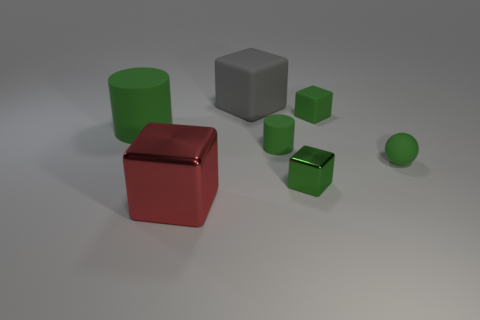Are the large red cube that is left of the tiny cylinder and the thing that is on the left side of the red shiny object made of the same material?
Ensure brevity in your answer.  No. Are there any small yellow cubes?
Ensure brevity in your answer.  No. Is the number of big red shiny blocks that are right of the large matte block greater than the number of large matte blocks that are on the left side of the large red thing?
Your answer should be compact. No. There is a red object that is the same shape as the tiny green metal object; what material is it?
Keep it short and to the point. Metal. Is there any other thing that has the same size as the gray rubber cube?
Your response must be concise. Yes. There is a large matte thing in front of the green rubber cube; is it the same color as the tiny rubber cylinder behind the small matte ball?
Your answer should be very brief. Yes. What is the shape of the red metal object?
Ensure brevity in your answer.  Cube. Is the number of green matte objects that are behind the red shiny thing greater than the number of large gray rubber spheres?
Give a very brief answer. Yes. The object that is left of the red object has what shape?
Make the answer very short. Cylinder. How many other things are there of the same shape as the gray matte object?
Your answer should be very brief. 3. 